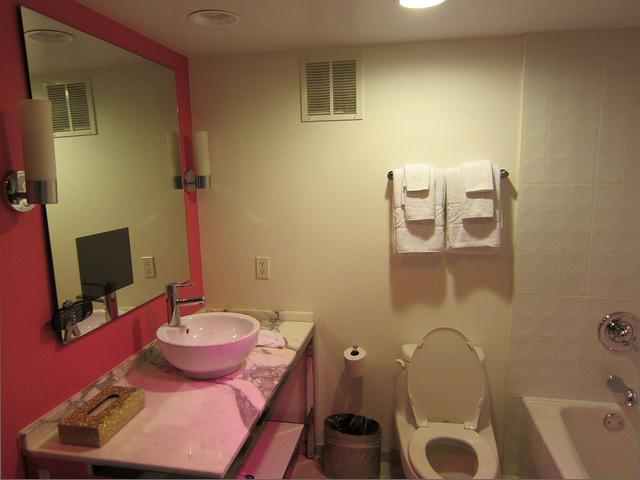What electronic device is embedded within the bathroom mirror in this bathroom? Please explain your reasoning. television. There is a tv. 